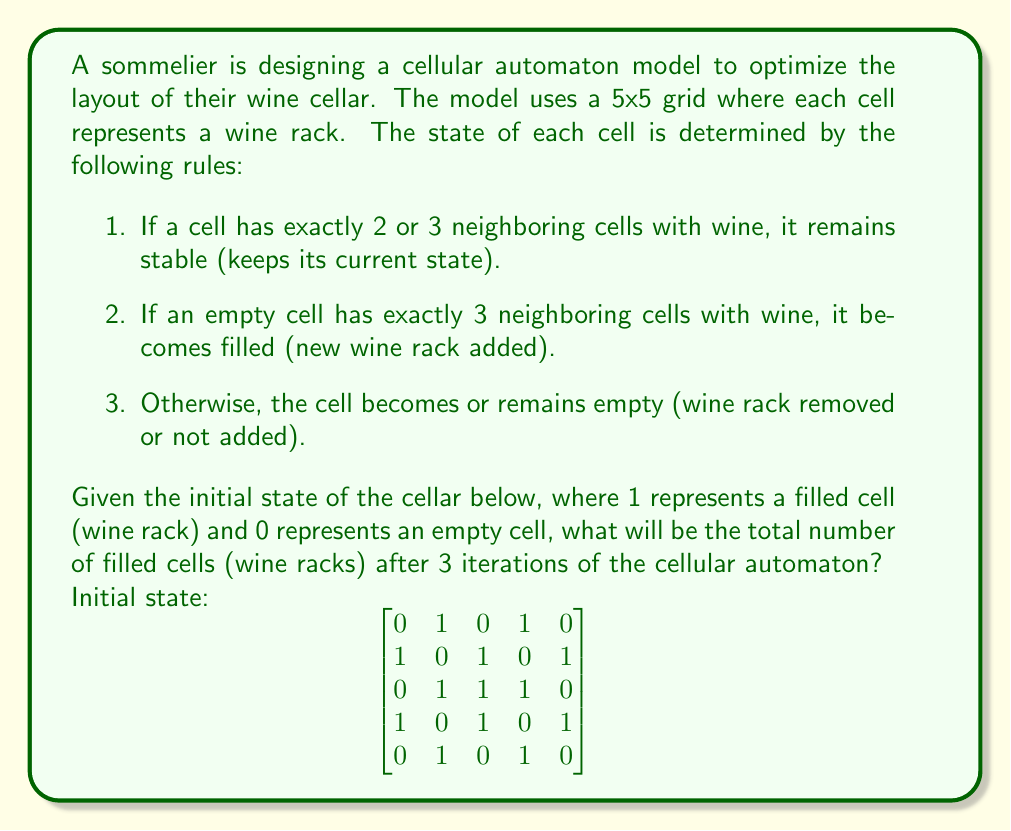Give your solution to this math problem. To solve this problem, we need to apply the cellular automaton rules for three iterations. Let's go through each iteration step-by-step:

Iteration 1:

1. Count the neighbors for each cell, including diagonals.
2. Apply the rules to determine the new state of each cell.

After the first iteration, the grid becomes:
$$
\begin{bmatrix}
0 & 1 & 1 & 1 & 0 \\
1 & 0 & 0 & 0 & 1 \\
1 & 0 & 0 & 0 & 1 \\
1 & 0 & 0 & 0 & 1 \\
0 & 1 & 1 & 1 & 0
\end{bmatrix}
$$

Iteration 2:

Applying the same process, we get:
$$
\begin{bmatrix}
0 & 1 & 1 & 1 & 0 \\
1 & 0 & 0 & 0 & 1 \\
1 & 0 & 0 & 0 & 1 \\
1 & 0 & 0 & 0 & 1 \\
0 & 1 & 1 & 1 & 0
\end{bmatrix}
$$

Iteration 3:

The grid remains the same as in iteration 2:
$$
\begin{bmatrix}
0 & 1 & 1 & 1 & 0 \\
1 & 0 & 0 & 0 & 1 \\
1 & 0 & 0 & 0 & 1 \\
1 & 0 & 0 & 0 & 1 \\
0 & 1 & 1 & 1 & 0
\end{bmatrix}
$$

To find the total number of filled cells, we count the number of 1's in the final grid.
Answer: 12 